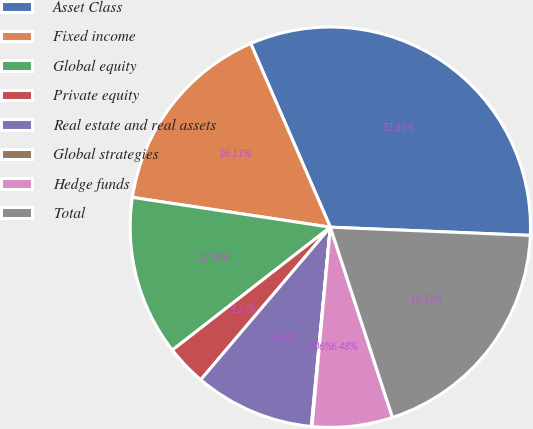Convert chart. <chart><loc_0><loc_0><loc_500><loc_500><pie_chart><fcel>Asset Class<fcel>Fixed income<fcel>Global equity<fcel>Private equity<fcel>Real estate and real assets<fcel>Global strategies<fcel>Hedge funds<fcel>Total<nl><fcel>32.16%<fcel>16.11%<fcel>12.9%<fcel>3.27%<fcel>9.69%<fcel>0.06%<fcel>6.48%<fcel>19.32%<nl></chart> 